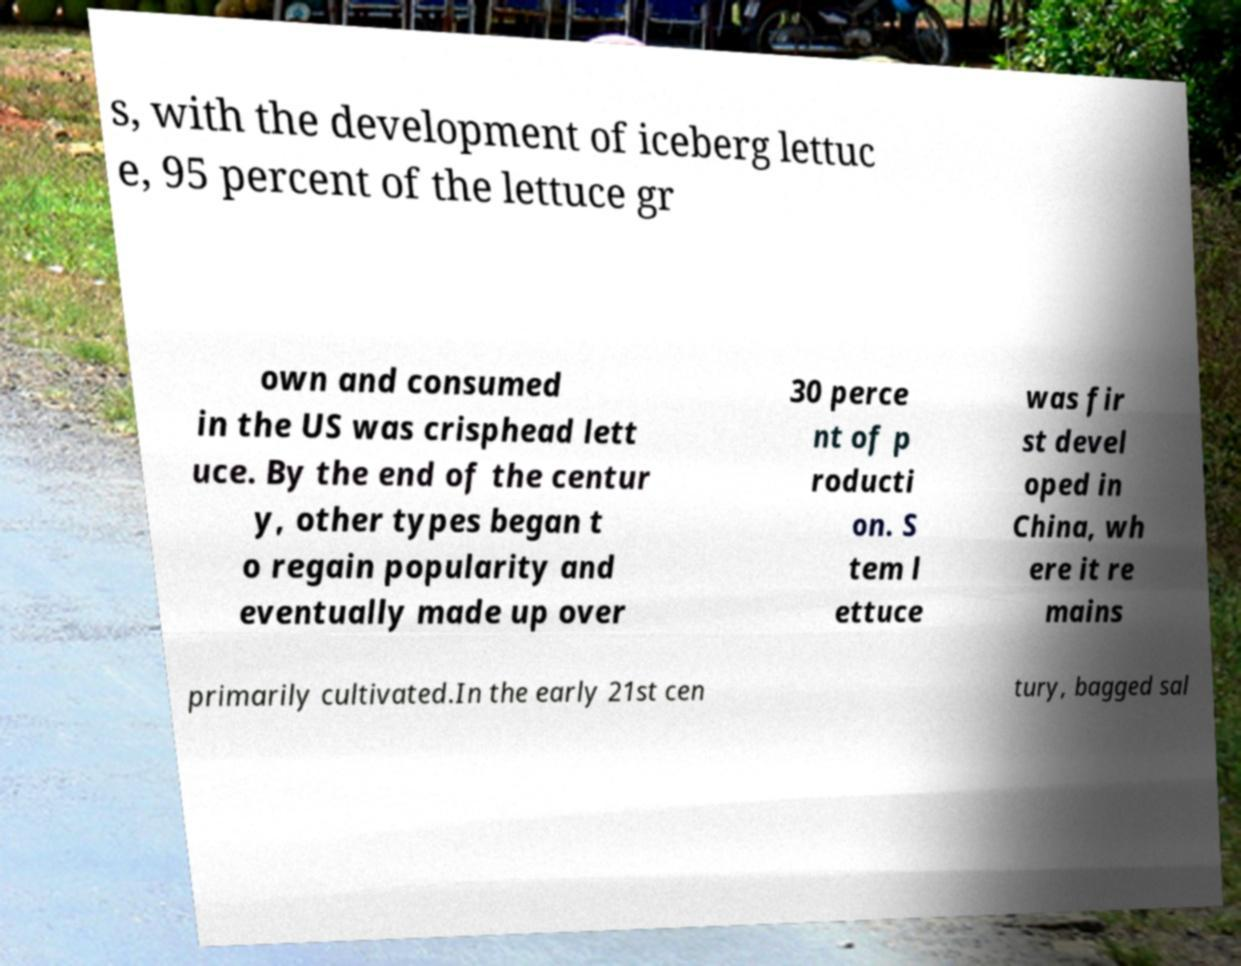Could you assist in decoding the text presented in this image and type it out clearly? s, with the development of iceberg lettuc e, 95 percent of the lettuce gr own and consumed in the US was crisphead lett uce. By the end of the centur y, other types began t o regain popularity and eventually made up over 30 perce nt of p roducti on. S tem l ettuce was fir st devel oped in China, wh ere it re mains primarily cultivated.In the early 21st cen tury, bagged sal 